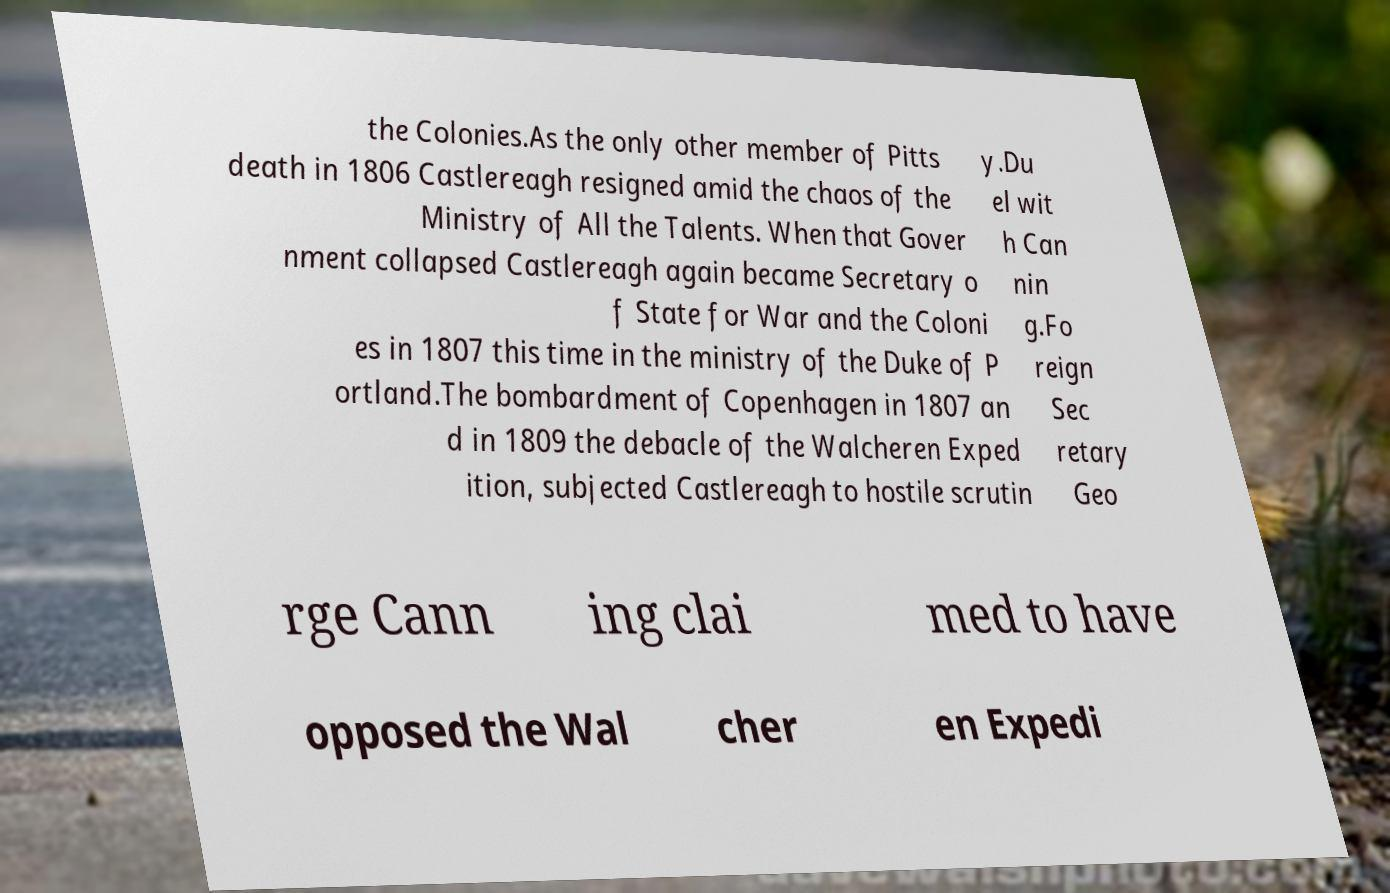For documentation purposes, I need the text within this image transcribed. Could you provide that? the Colonies.As the only other member of Pitts death in 1806 Castlereagh resigned amid the chaos of the Ministry of All the Talents. When that Gover nment collapsed Castlereagh again became Secretary o f State for War and the Coloni es in 1807 this time in the ministry of the Duke of P ortland.The bombardment of Copenhagen in 1807 an d in 1809 the debacle of the Walcheren Exped ition, subjected Castlereagh to hostile scrutin y.Du el wit h Can nin g.Fo reign Sec retary Geo rge Cann ing clai med to have opposed the Wal cher en Expedi 